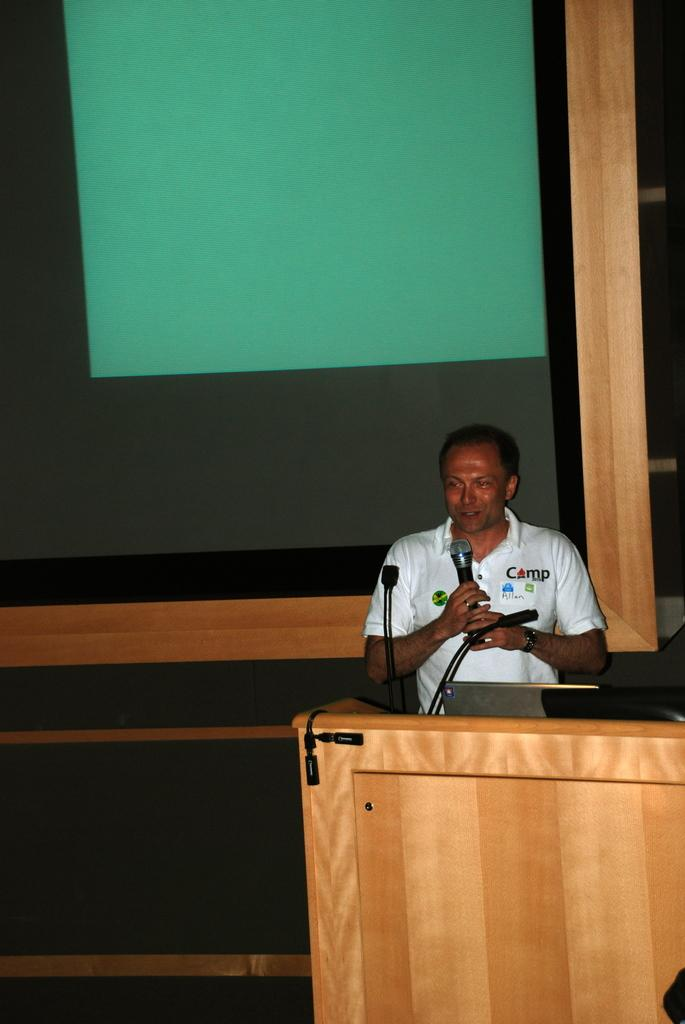What is the man doing in the image? The man is holding a microphone in the image. What object is in front of the man? There is a podium in front of the man. Where is the man located in the image? The man is on the right side of the image. What type of bread is being used as a prop on the podium? There is no bread present in the image, and therefore it cannot be used as a prop on the podium. 